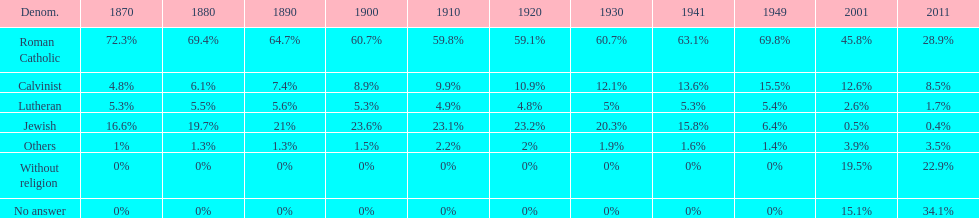Which religious denomination had a higher percentage in 1900, jewish or roman catholic? Roman Catholic. 